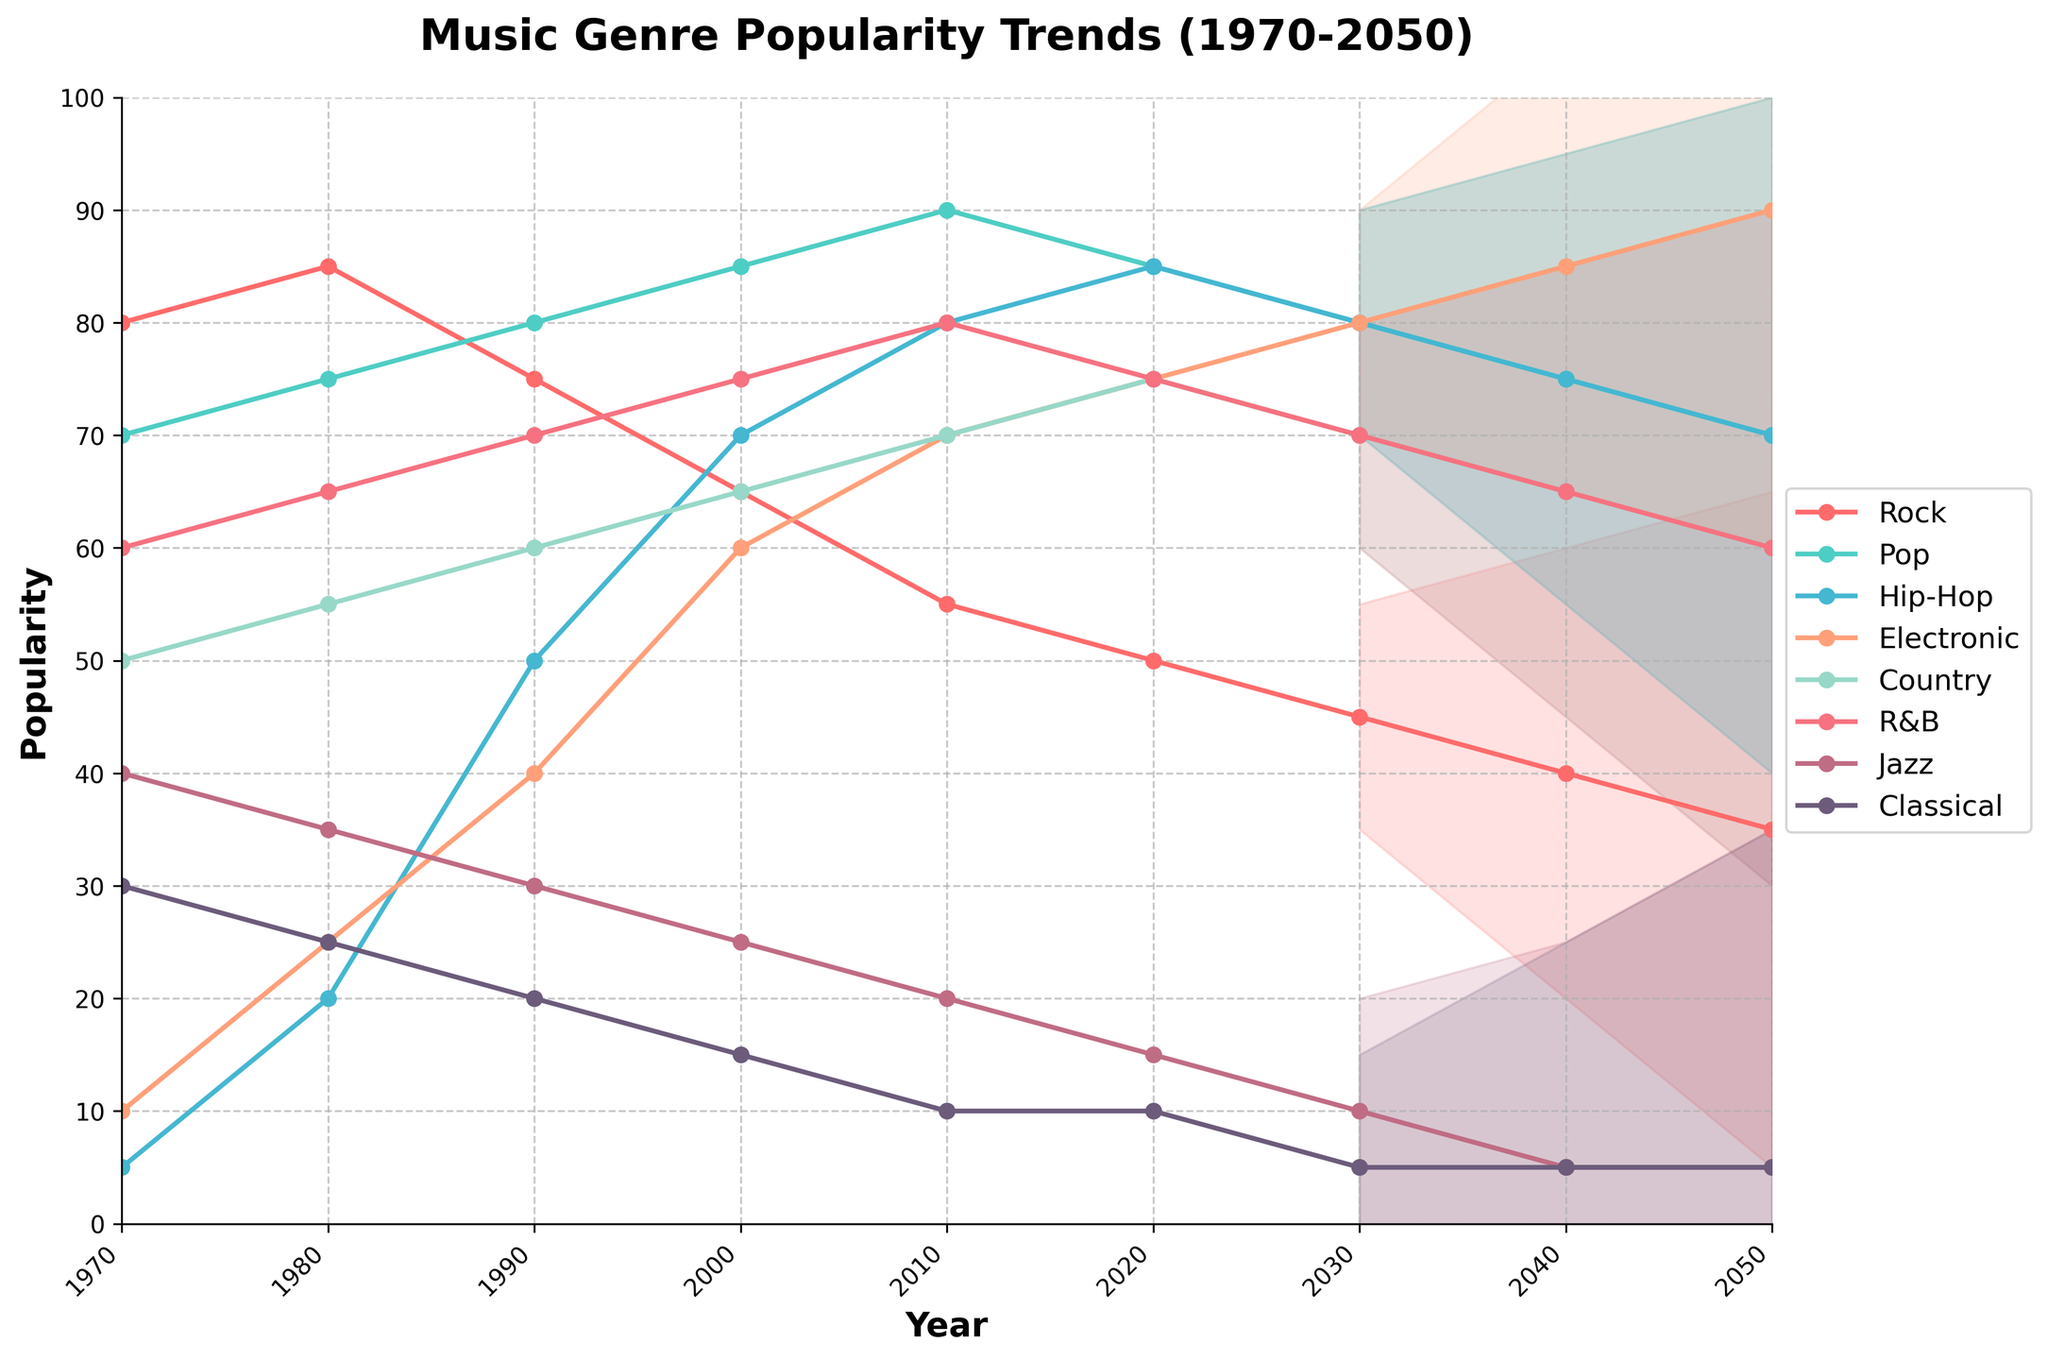What is the title of the figure? The title is displayed at the top of the figure in bold font.
Answer: Music Genre Popularity Trends (1970-2050) Which genre had the highest popularity in 1990? By looking at the data points plotted for 1990, the highest value can be observed.
Answer: Pop How does the popularity of Classical music change from 1970 to 2020? By observing the line representing Classical music, identify its initial and final popularity values.
Answer: Decreases from 30 to 10 What is the range of popularity forecasted for Rock music in 2050? The forecast fan chart for Rock music provides upper and lower bounds at 2050.
Answer: 5 to 65 How many genres have their popularity forecasted with uncertainty in 2040? The shaded regions in the forecast portion show how many genres include forecast uncertainty in 2040.
Answer: 8 Which genre is predicted to have the lowest popularity in 2050? By observing the forecasted data points for all genres at 2050, the lowest value can be identified.
Answer: Classical Between which years does Hip-Hop music's popularity increase the most rapidly? By comparing the slope of Hip-Hop's popularity line between different years, the steepest increase can be identified.
Answer: 1980 to 2000 In what year did Electronic music first surpass 50 in popularity? By tracking the Electronic music line, identify the first year it reaches a value of 50 or more.
Answer: 1990 What trend do you observe for the popularity of Rock music over the entire period? By following the Rock music line, determine if the general trend is increasing, decreasing, or fluctuating.
Answer: Decreasing What's the maximum forecast uncertainty value observed, and in which year? By identifying the maximum value from the Forecast Uncertainty column and referring to the corresponding year.
Answer: 30 in 2050 